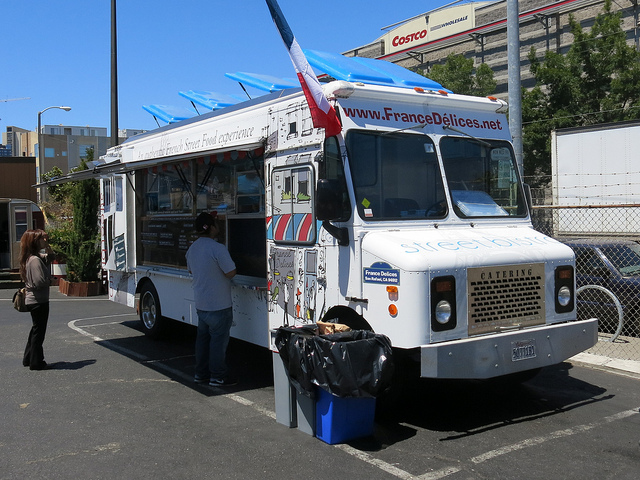<image>What is the best selling product? It is unknown what the best selling product is. However, it may be ice cream based on some responses. What is the best selling product? I don't know what the best selling product is. It can be pastries, ice cream sandwich, sandwich, food, or ice cream. 